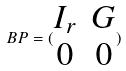<formula> <loc_0><loc_0><loc_500><loc_500>B P = ( \begin{matrix} I _ { r } & G \\ 0 & 0 \end{matrix} )</formula> 